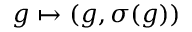<formula> <loc_0><loc_0><loc_500><loc_500>g \mapsto ( g , \sigma ( g ) )</formula> 